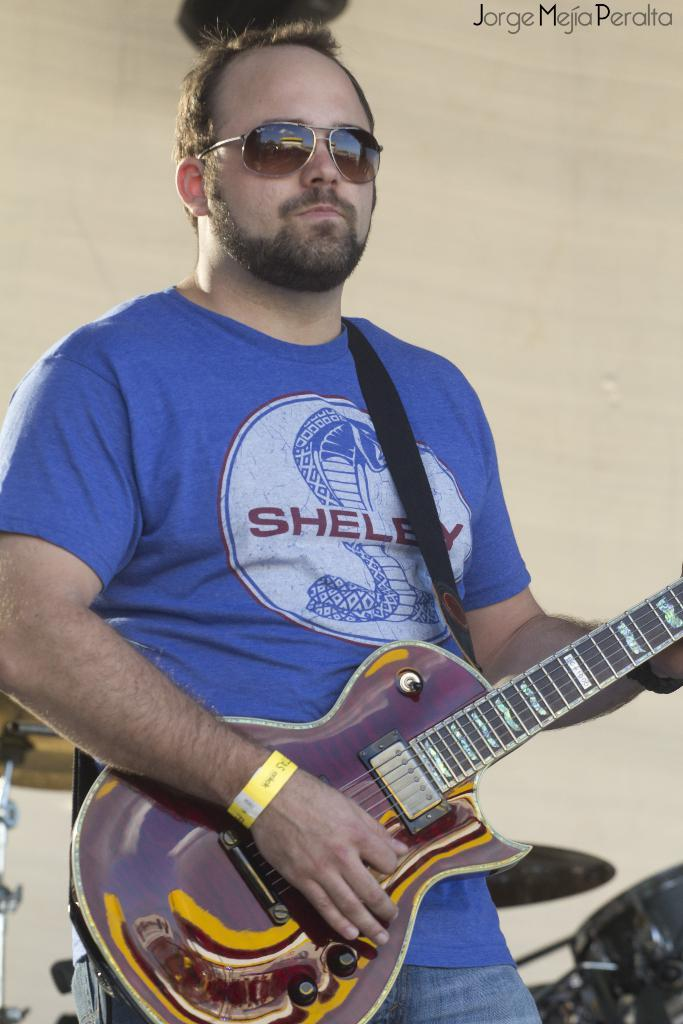Who is the main subject in the image? There is a man in the center of the image. What is the man doing in the image? The man is standing and playing a guitar. What can be seen in the background of the image? There is a wall in the background of the image. What type of insurance does the man have for his guitar in the image? There is no information about insurance for the guitar in the image. 